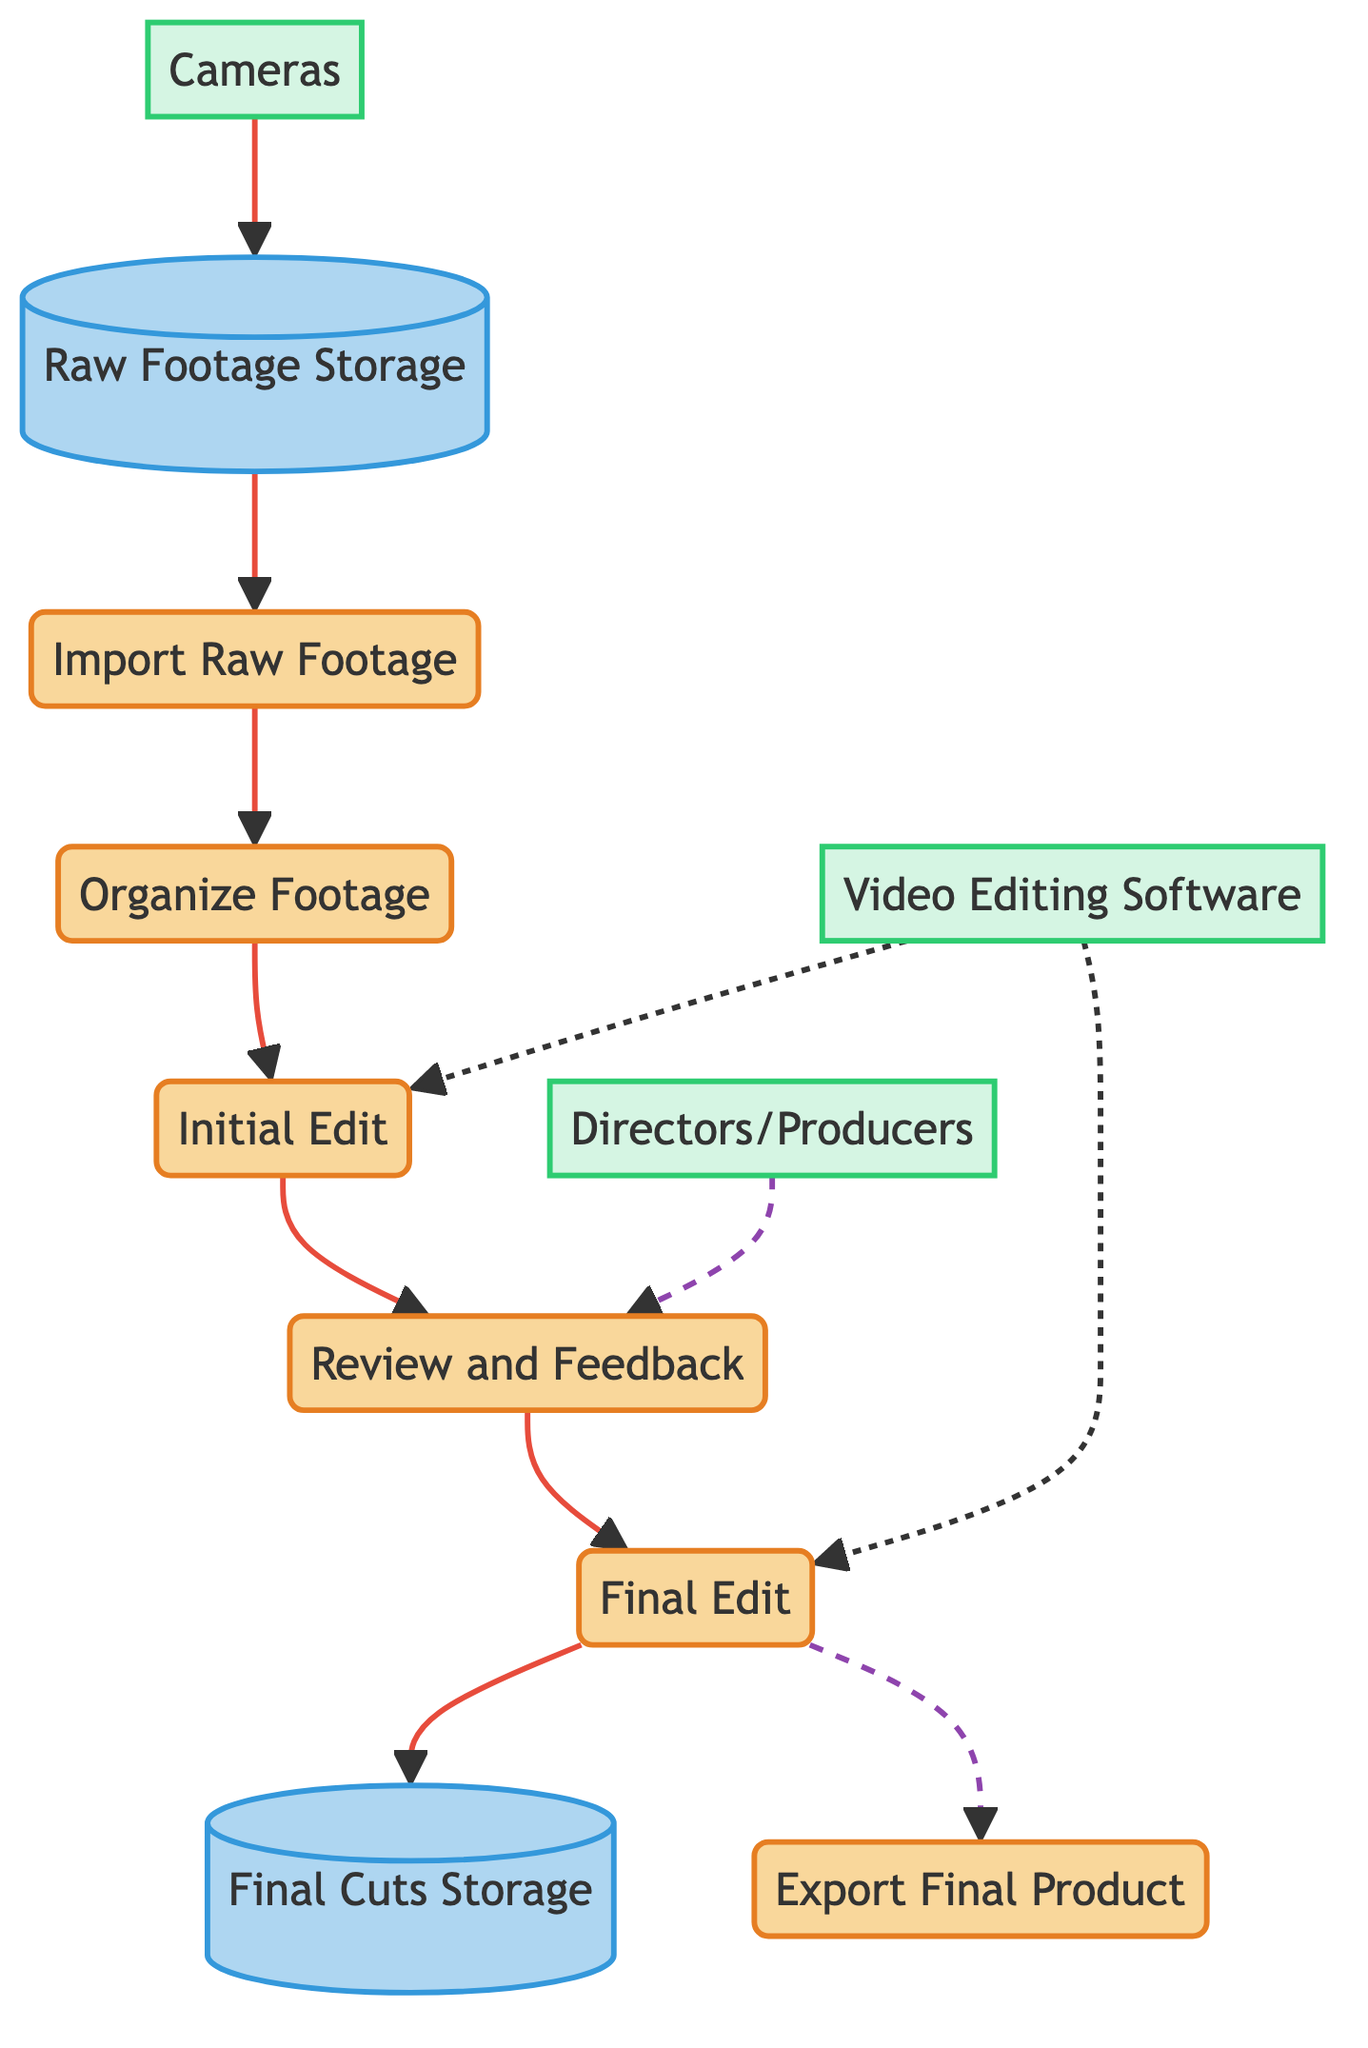What is the first process in the diagram? The diagram indicates that the first process is "Import Raw Footage," as it is the initial step where raw footage is imported.
Answer: Import Raw Footage How many processes are there in total? Counting all labeled processes in the diagram, there is a total of six processes from "Import Raw Footage" to "Export Final Product."
Answer: 6 Which external entity provides feedback during the review process? According to the diagram, "Directors/Producers" is the external entity that supplies feedback for the "Review and Feedback" step.
Answer: Directors/Producers What data store holds the final edited versions? The diagram specifies that "Final Cuts Storage" is the data store that keeps the final edited versions of the footage.
Answer: Final Cuts Storage In which process does the organized footage transition into rough cuts? The diagram shows that organized footage is passed to the "Initial Edit" process to create rough cuts from the organized footage.
Answer: Initial Edit How many data flows are shown in the diagram? By examining the diagram, there are a total of eight distinct data flows connecting various processes and external entities.
Answer: 8 Which software is indicated to be used for editing? The diagram explicitly references "Video Editing Software" as the tools utilized for the editing processes, specifically mentioned for "Initial Edit" and "Final Edit."
Answer: Video Editing Software What action occurs after receiving feedback from the directors/producers? Following feedback from the directors/producers, the next step in the process is "Final Edit," where feedback is implemented.
Answer: Final Edit Which process involves exporting the final product? According to the diagram, the last step of the process that entails exporting is labeled "Export Final Product."
Answer: Export Final Product 